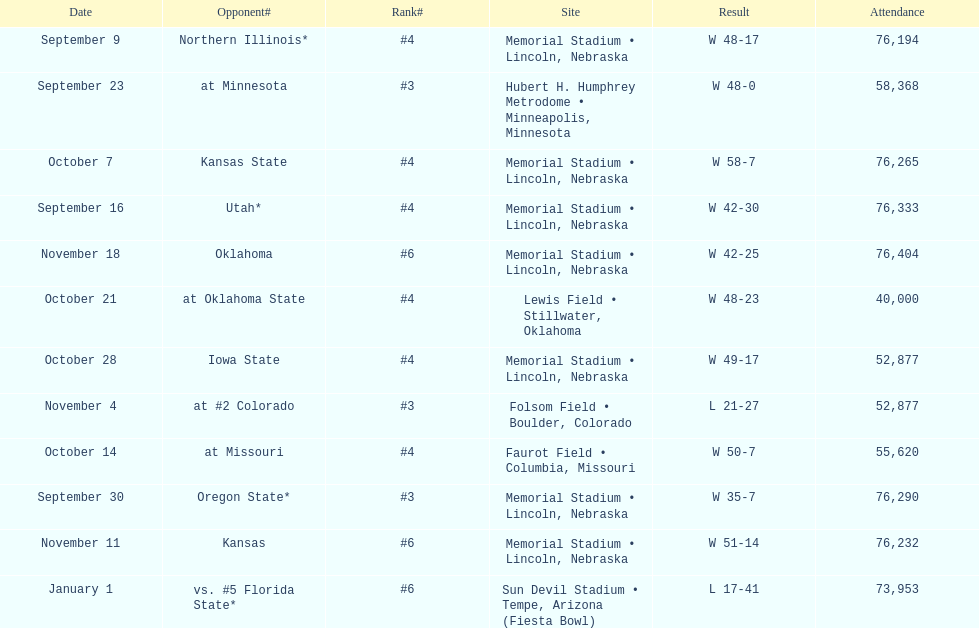When is the first game? September 9. 